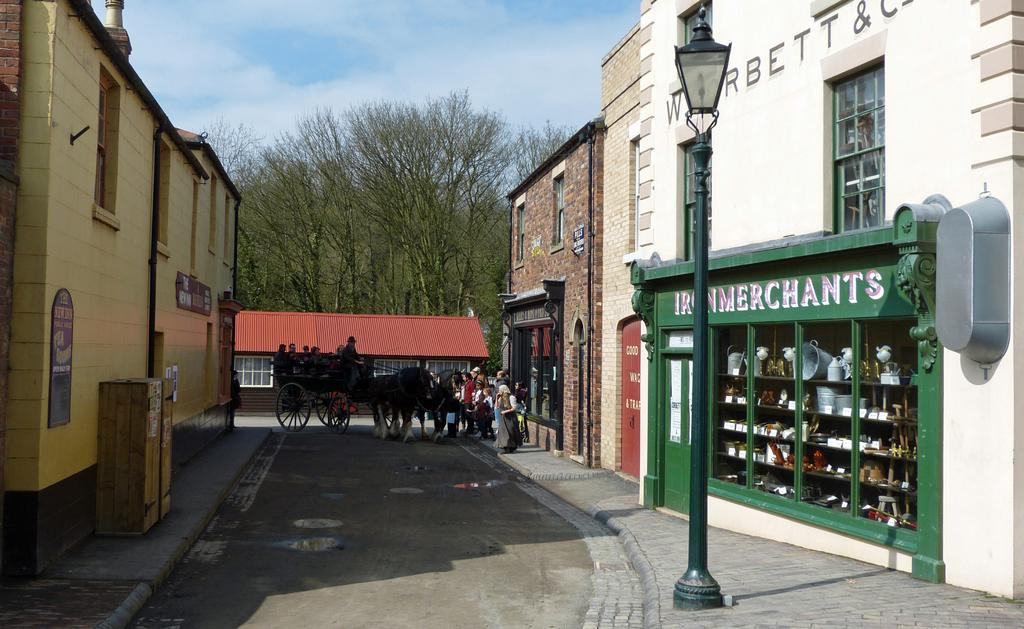<image>
Describe the image concisely. A building with an Iron Merchants sign in front of a store. 